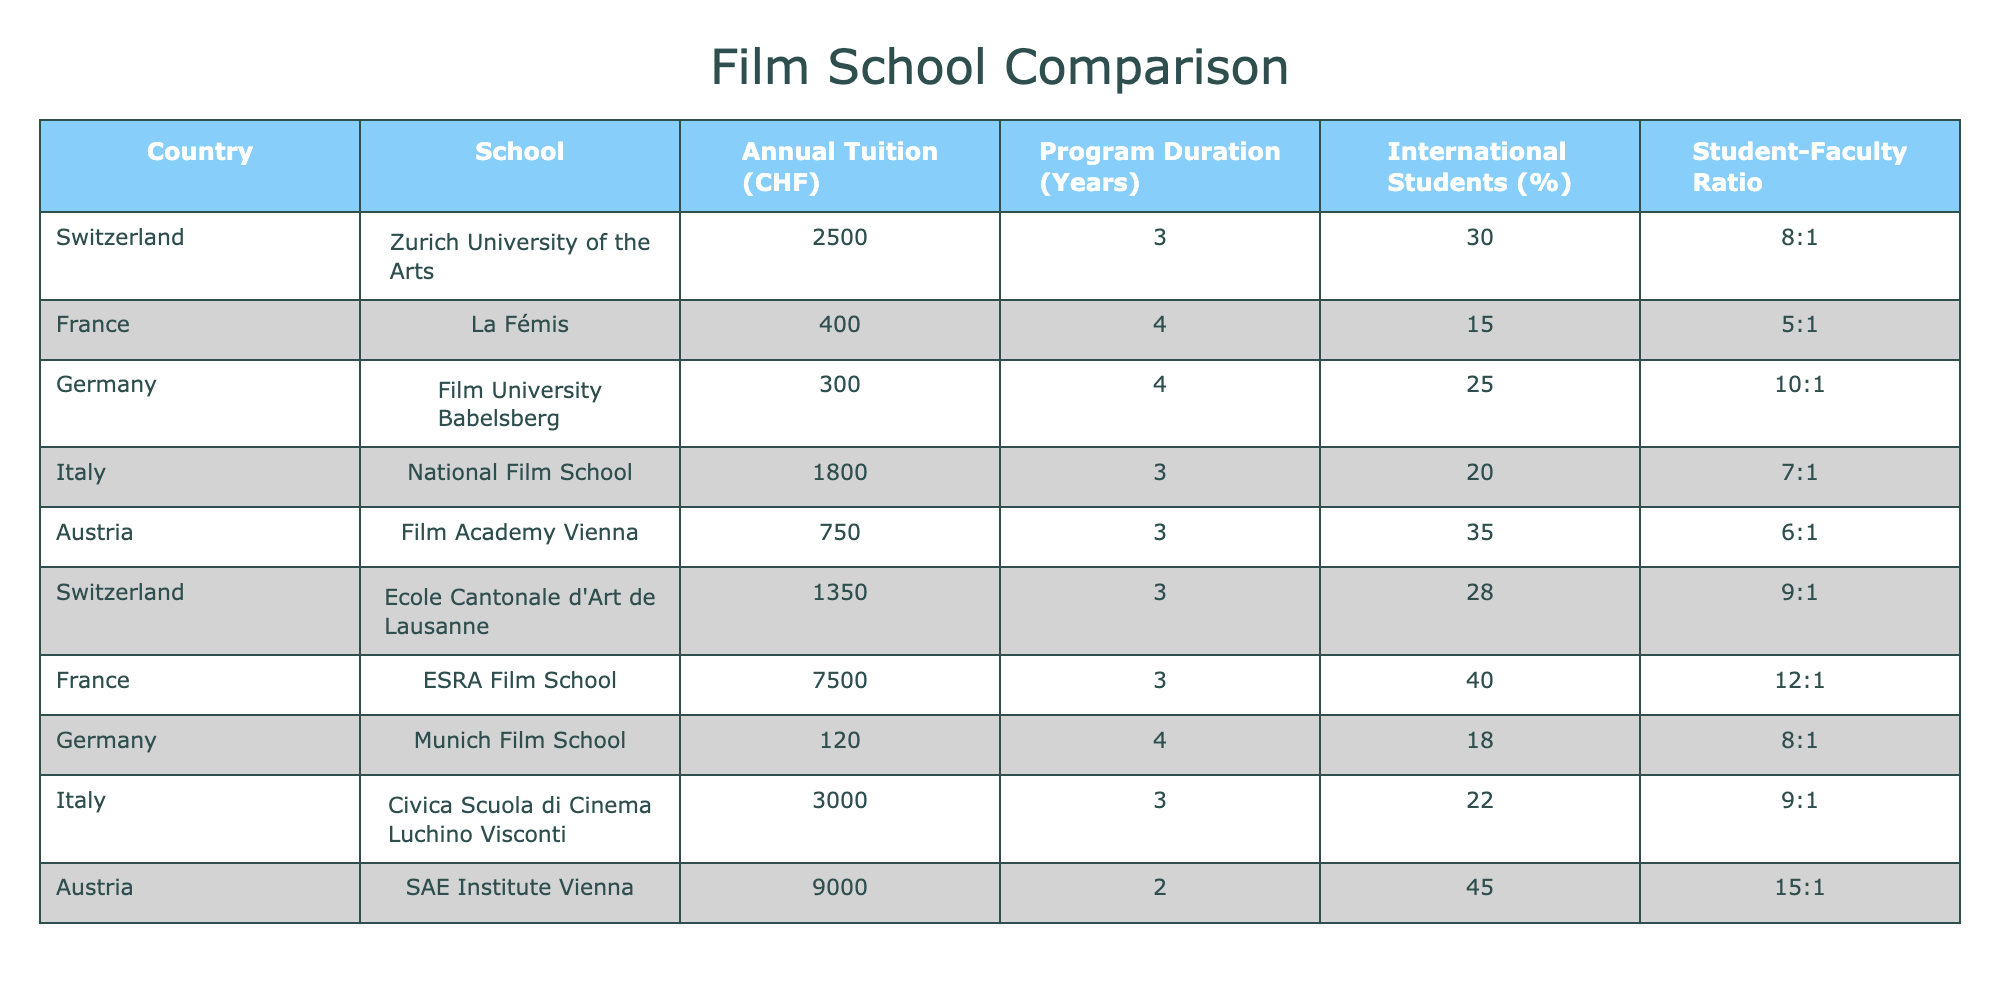What's the annual tuition of the Munich Film School? The table lists the Munich Film School under Germany with an annual tuition of 120 CHF.
Answer: 120 CHF Which film school has the highest tuition in the table? The ESRA Film School in France has the highest tuition at 7500 CHF according to the table.
Answer: 7500 CHF What is the program duration of the Film Academy Vienna? The table shows that the program duration for the Film Academy Vienna in Austria is 3 years.
Answer: 3 years How much does it cost to attend film school in Switzerland compared to Germany? The annual tuition for Zurich University of the Arts in Switzerland is 2500 CHF, while Film University Babelsberg in Germany costs 300 CHF.
Answer: 2500 CHF vs. 300 CHF What is the average annual tuition cost for film schools in Switzerland? The annual tuition costs for Swiss film schools are 2500 CHF and 1350 CHF. Calculating the average: (2500 + 1350) / 2 = 1925 CHF.
Answer: 1925 CHF Which country has the highest percentage of international students among the listed film schools? The SAE Institute Vienna in Austria has the highest percentage of international students at 45%.
Answer: Austria (45%) Is the student-faculty ratio better (lower) in the Ecole Cantonale d'Art de Lausanne or the Film Academy Vienna? The Ecole Cantonale d'Art de Lausanne has a student-faculty ratio of 9:1, while the Film Academy Vienna has a ratio of 6:1. A lower ratio means better direct access to faculty.
Answer: Film Academy Vienna What is the tuition difference between the top two most expensive film schools? The tuition for the ESRA Film School is 7500 CHF, and SAE Institute Vienna is 9000 CHF. The difference is 9000 - 7500 = 1500 CHF.
Answer: 1500 CHF Which film school has the highest student-faculty ratio? The SAE Institute Vienna has the highest student-faculty ratio of 15:1 among the listed schools.
Answer: 15:1 If I want to study for 4 years, which film school in Germany should I choose to minimize tuition? The Film University Babelsberg has the lowest tuition at 300 CHF for a 4-year program compared to Munich Film School which charges 120 CHF. The total for Babelsberg is 300 * 4 = 1200 CHF.
Answer: Film University Babelsberg What percentage of international students does the La Fémis have compared to Zurich University's percentage? La Fémis has 15% international students while Zurich University has 30%. To find the difference: 30% - 15% = 15%.
Answer: 15% 